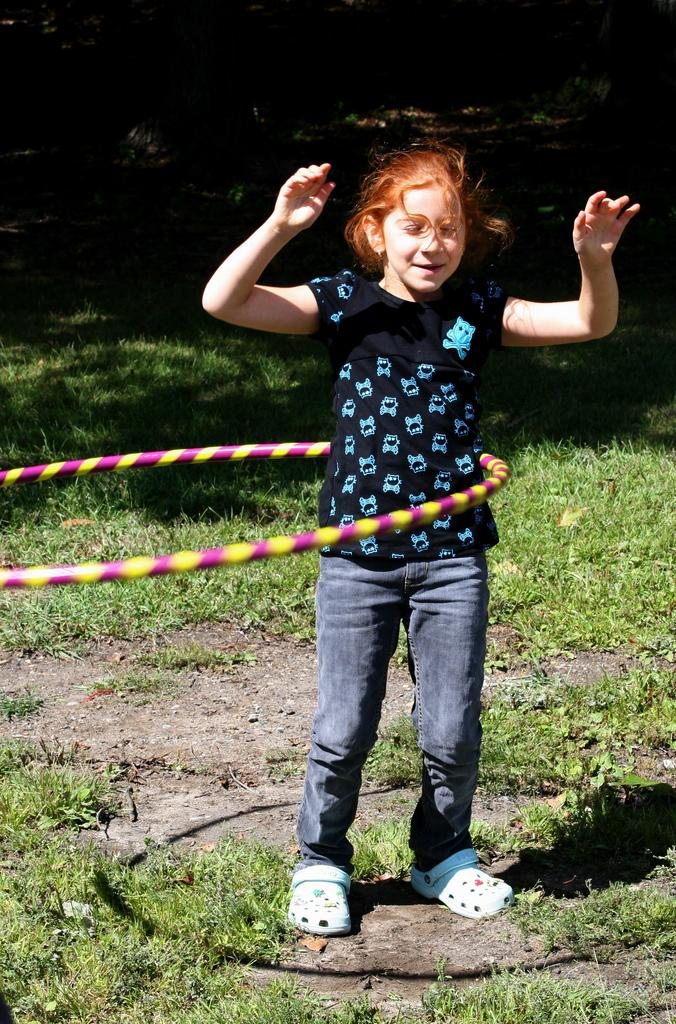What object is featured in the image? There is a hula hoop ring in the image. What is the girl in the image doing? The girl is standing on the ground in the image. What type of terrain is visible in the background? The background of the image includes grass. How would you describe the overall lighting in the image? The image has a dark background. What type of umbrella is the girl holding in the image? There is no umbrella present in the image. What sense does the girl appear to be using while standing on the ground? The image does not provide enough information to determine which sense the girl is using. 